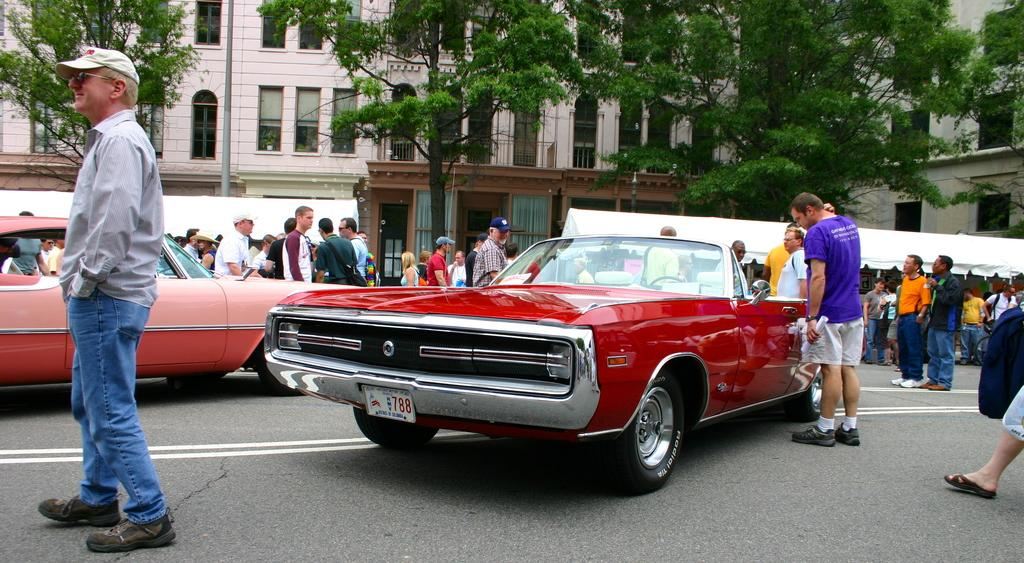How many people are in the image? There is a group of people in the image, but the exact number cannot be determined from the provided facts. What else can be seen in the image besides the group of people? Cars, trees, a tent, buildings, and windows are visible in the image. Can you describe the setting of the image? The image appears to be outdoors, given the presence of trees and a tent. What type of structures are present in the image? Buildings are present in the image. Where is the cobweb located in the image? There is no cobweb present in the image. What type of drink is being served in the image? The provided facts do not mention any drinks, so it cannot be determined what is being served in the image. 